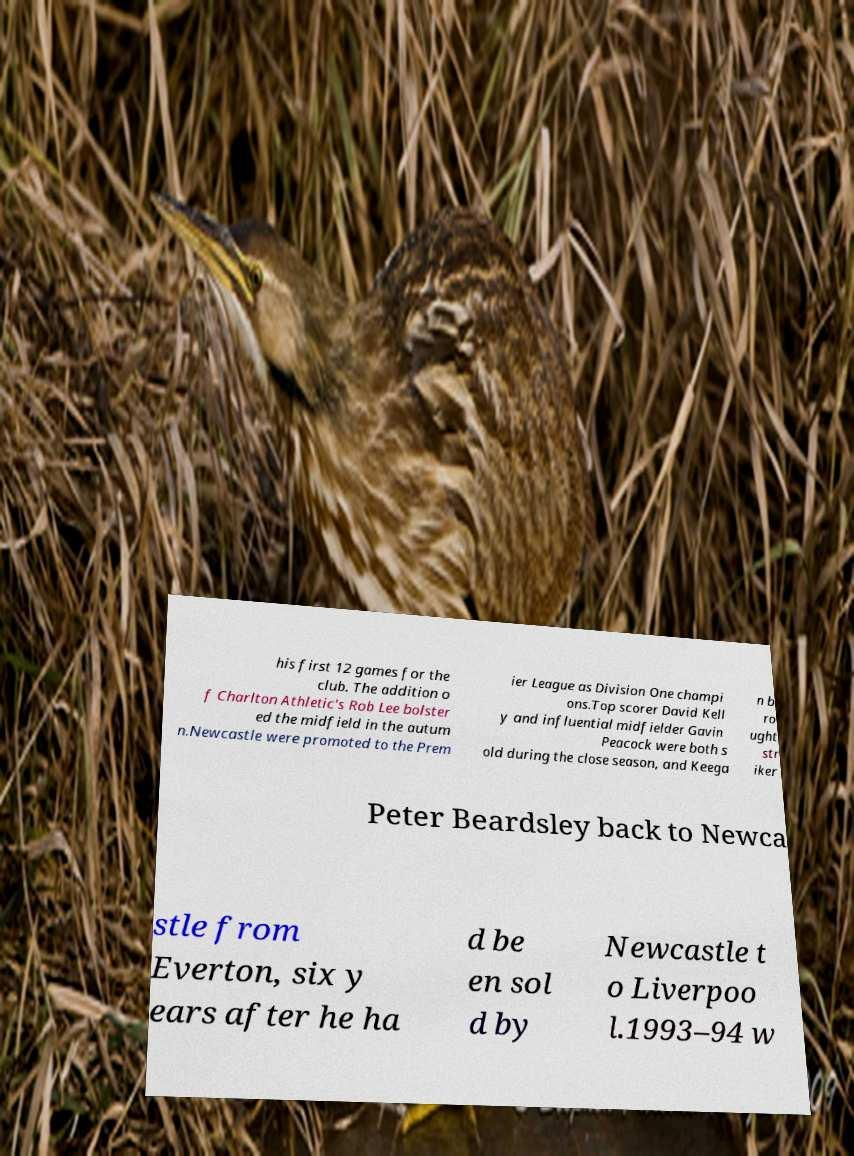Please identify and transcribe the text found in this image. his first 12 games for the club. The addition o f Charlton Athletic's Rob Lee bolster ed the midfield in the autum n.Newcastle were promoted to the Prem ier League as Division One champi ons.Top scorer David Kell y and influential midfielder Gavin Peacock were both s old during the close season, and Keega n b ro ught str iker Peter Beardsley back to Newca stle from Everton, six y ears after he ha d be en sol d by Newcastle t o Liverpoo l.1993–94 w 